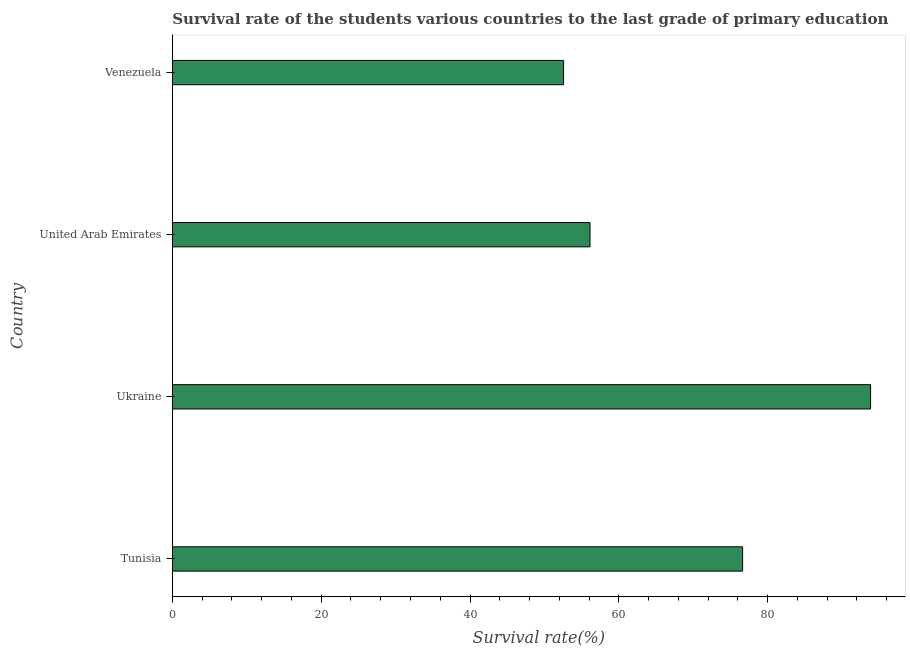What is the title of the graph?
Make the answer very short. Survival rate of the students various countries to the last grade of primary education. What is the label or title of the X-axis?
Give a very brief answer. Survival rate(%). What is the label or title of the Y-axis?
Your answer should be compact. Country. What is the survival rate in primary education in United Arab Emirates?
Make the answer very short. 56.13. Across all countries, what is the maximum survival rate in primary education?
Ensure brevity in your answer.  93.83. Across all countries, what is the minimum survival rate in primary education?
Your response must be concise. 52.58. In which country was the survival rate in primary education maximum?
Your answer should be very brief. Ukraine. In which country was the survival rate in primary education minimum?
Offer a very short reply. Venezuela. What is the sum of the survival rate in primary education?
Make the answer very short. 279.17. What is the difference between the survival rate in primary education in United Arab Emirates and Venezuela?
Make the answer very short. 3.55. What is the average survival rate in primary education per country?
Ensure brevity in your answer.  69.79. What is the median survival rate in primary education?
Offer a terse response. 66.38. In how many countries, is the survival rate in primary education greater than 12 %?
Offer a terse response. 4. What is the ratio of the survival rate in primary education in United Arab Emirates to that in Venezuela?
Your answer should be compact. 1.07. Is the survival rate in primary education in Ukraine less than that in Venezuela?
Give a very brief answer. No. Is the difference between the survival rate in primary education in Tunisia and Ukraine greater than the difference between any two countries?
Your answer should be compact. No. What is the difference between the highest and the second highest survival rate in primary education?
Give a very brief answer. 17.2. What is the difference between the highest and the lowest survival rate in primary education?
Provide a succinct answer. 41.26. What is the difference between two consecutive major ticks on the X-axis?
Give a very brief answer. 20. What is the Survival rate(%) in Tunisia?
Your response must be concise. 76.64. What is the Survival rate(%) of Ukraine?
Provide a succinct answer. 93.83. What is the Survival rate(%) in United Arab Emirates?
Your answer should be compact. 56.13. What is the Survival rate(%) of Venezuela?
Offer a very short reply. 52.58. What is the difference between the Survival rate(%) in Tunisia and Ukraine?
Give a very brief answer. -17.2. What is the difference between the Survival rate(%) in Tunisia and United Arab Emirates?
Provide a succinct answer. 20.51. What is the difference between the Survival rate(%) in Tunisia and Venezuela?
Provide a succinct answer. 24.06. What is the difference between the Survival rate(%) in Ukraine and United Arab Emirates?
Keep it short and to the point. 37.71. What is the difference between the Survival rate(%) in Ukraine and Venezuela?
Your answer should be very brief. 41.26. What is the difference between the Survival rate(%) in United Arab Emirates and Venezuela?
Give a very brief answer. 3.55. What is the ratio of the Survival rate(%) in Tunisia to that in Ukraine?
Give a very brief answer. 0.82. What is the ratio of the Survival rate(%) in Tunisia to that in United Arab Emirates?
Provide a succinct answer. 1.36. What is the ratio of the Survival rate(%) in Tunisia to that in Venezuela?
Give a very brief answer. 1.46. What is the ratio of the Survival rate(%) in Ukraine to that in United Arab Emirates?
Your response must be concise. 1.67. What is the ratio of the Survival rate(%) in Ukraine to that in Venezuela?
Keep it short and to the point. 1.78. What is the ratio of the Survival rate(%) in United Arab Emirates to that in Venezuela?
Your answer should be compact. 1.07. 